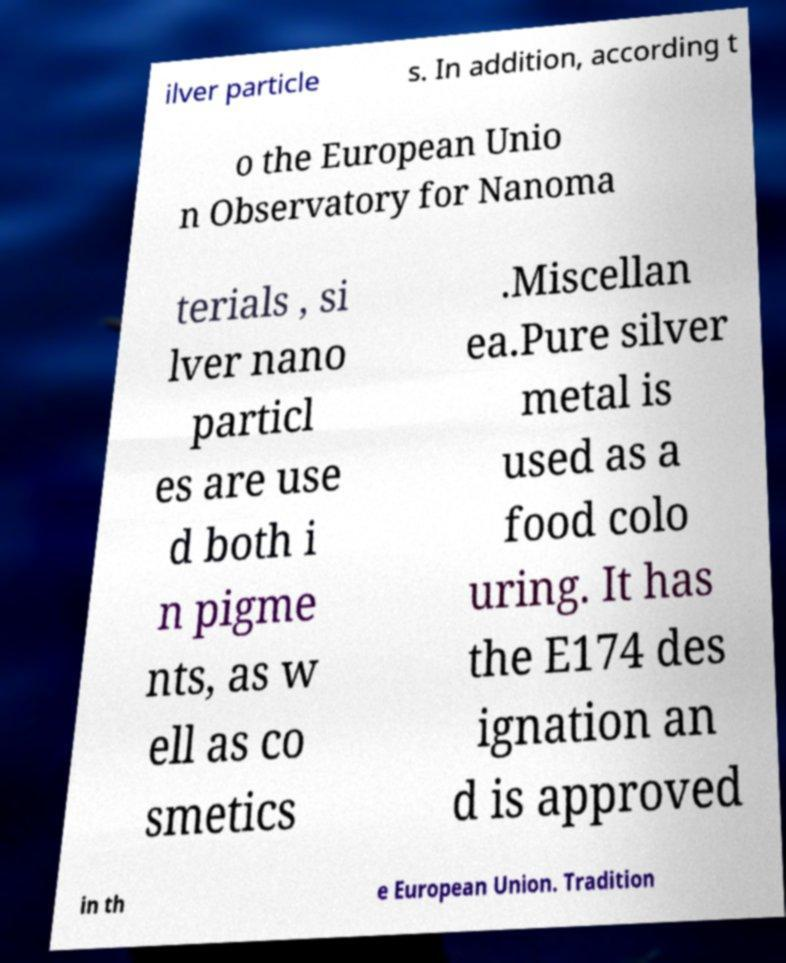Could you extract and type out the text from this image? ilver particle s. In addition, according t o the European Unio n Observatory for Nanoma terials , si lver nano particl es are use d both i n pigme nts, as w ell as co smetics .Miscellan ea.Pure silver metal is used as a food colo uring. It has the E174 des ignation an d is approved in th e European Union. Tradition 